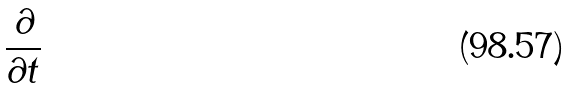<formula> <loc_0><loc_0><loc_500><loc_500>\frac { \partial } { \partial t }</formula> 